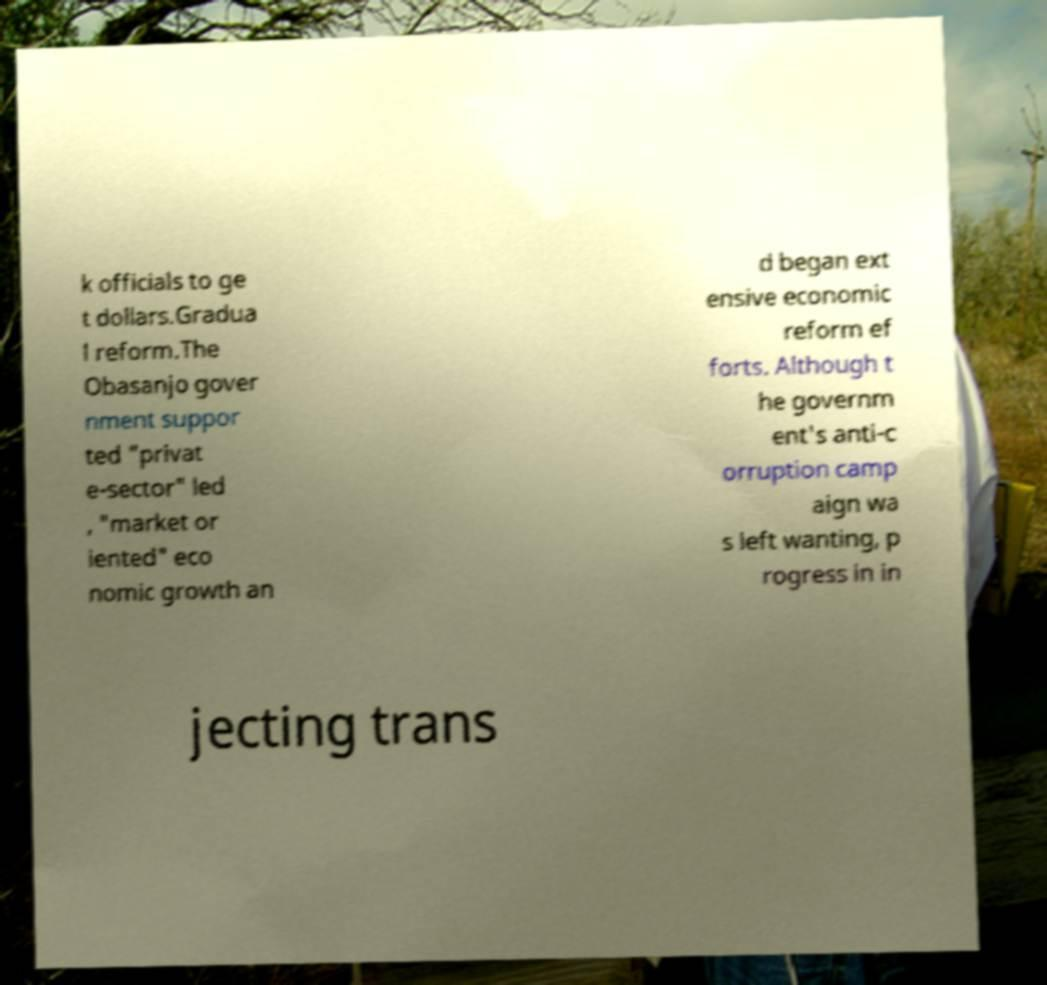There's text embedded in this image that I need extracted. Can you transcribe it verbatim? k officials to ge t dollars.Gradua l reform.The Obasanjo gover nment suppor ted "privat e-sector" led , "market or iented" eco nomic growth an d began ext ensive economic reform ef forts. Although t he governm ent's anti-c orruption camp aign wa s left wanting, p rogress in in jecting trans 